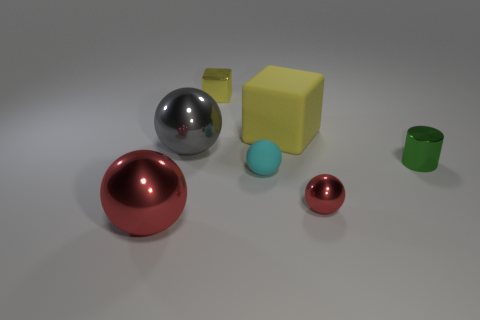What size is the yellow thing that is the same material as the gray ball?
Provide a short and direct response. Small. The red thing left of the tiny ball that is right of the large yellow object is what shape?
Give a very brief answer. Sphere. What is the size of the metal object that is both on the right side of the tiny cyan matte thing and behind the cyan object?
Provide a short and direct response. Small. Is there a green shiny thing that has the same shape as the small matte thing?
Offer a terse response. No. Is there any other thing that is the same shape as the yellow metal object?
Your response must be concise. Yes. What is the material of the large sphere in front of the red ball that is right of the big sphere that is in front of the green metal thing?
Offer a terse response. Metal. Are there any rubber blocks of the same size as the shiny cylinder?
Ensure brevity in your answer.  No. There is a big shiny thing to the right of the big thing in front of the tiny cyan object; what is its color?
Ensure brevity in your answer.  Gray. How many matte objects are there?
Provide a succinct answer. 2. Do the cylinder and the small shiny block have the same color?
Keep it short and to the point. No. 